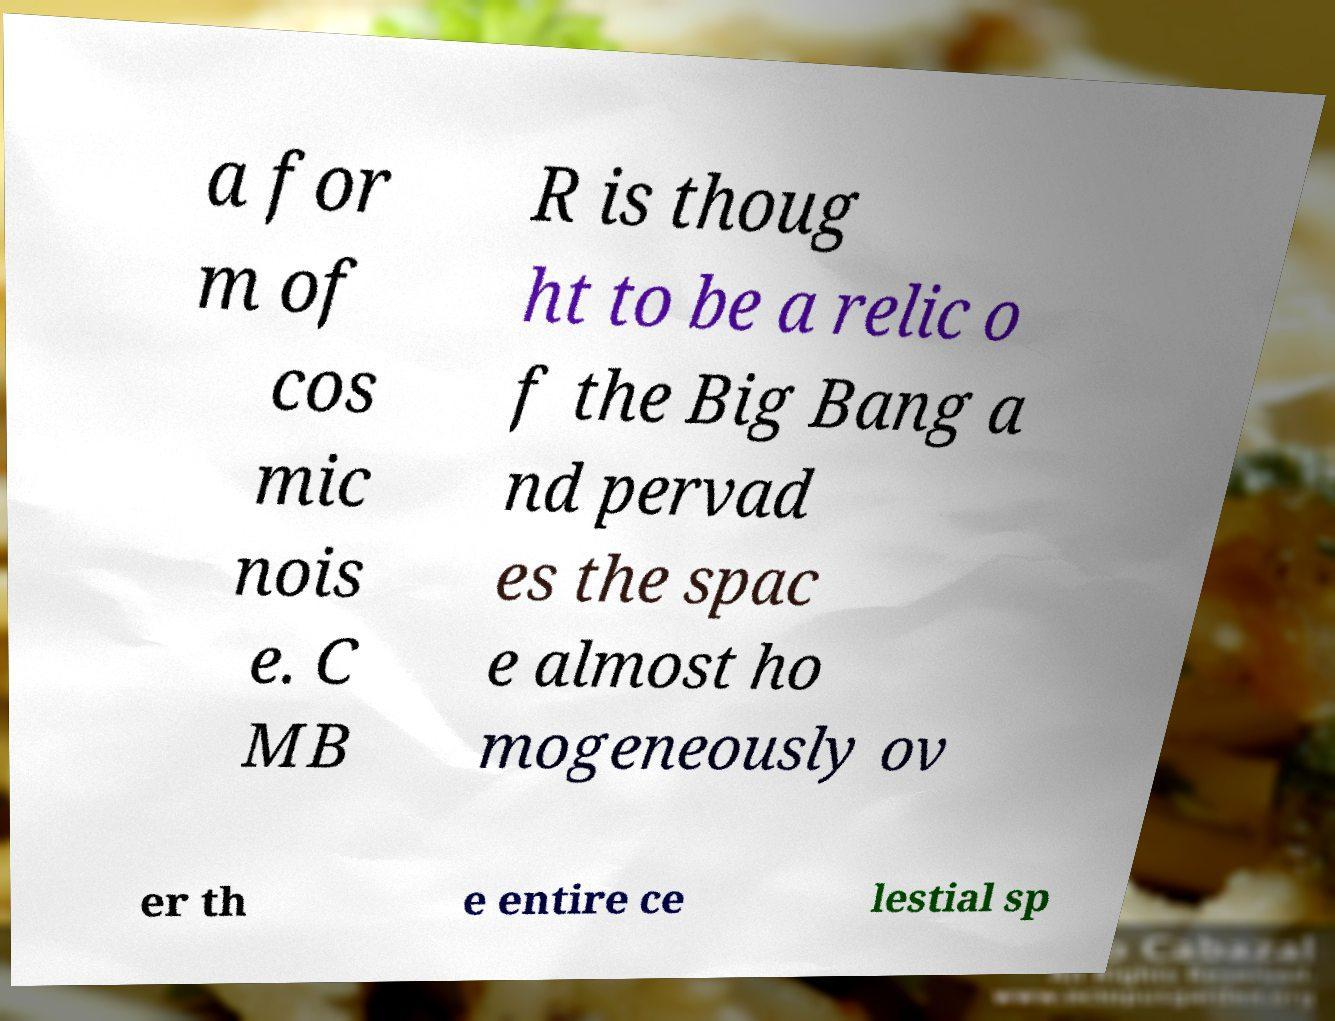What messages or text are displayed in this image? I need them in a readable, typed format. a for m of cos mic nois e. C MB R is thoug ht to be a relic o f the Big Bang a nd pervad es the spac e almost ho mogeneously ov er th e entire ce lestial sp 